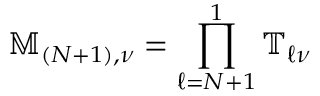<formula> <loc_0><loc_0><loc_500><loc_500>\mathbb { M } _ { ( N + 1 ) , \nu } = \prod _ { \ell = N + 1 } ^ { 1 } \mathbb { T } _ { \ell \nu }</formula> 